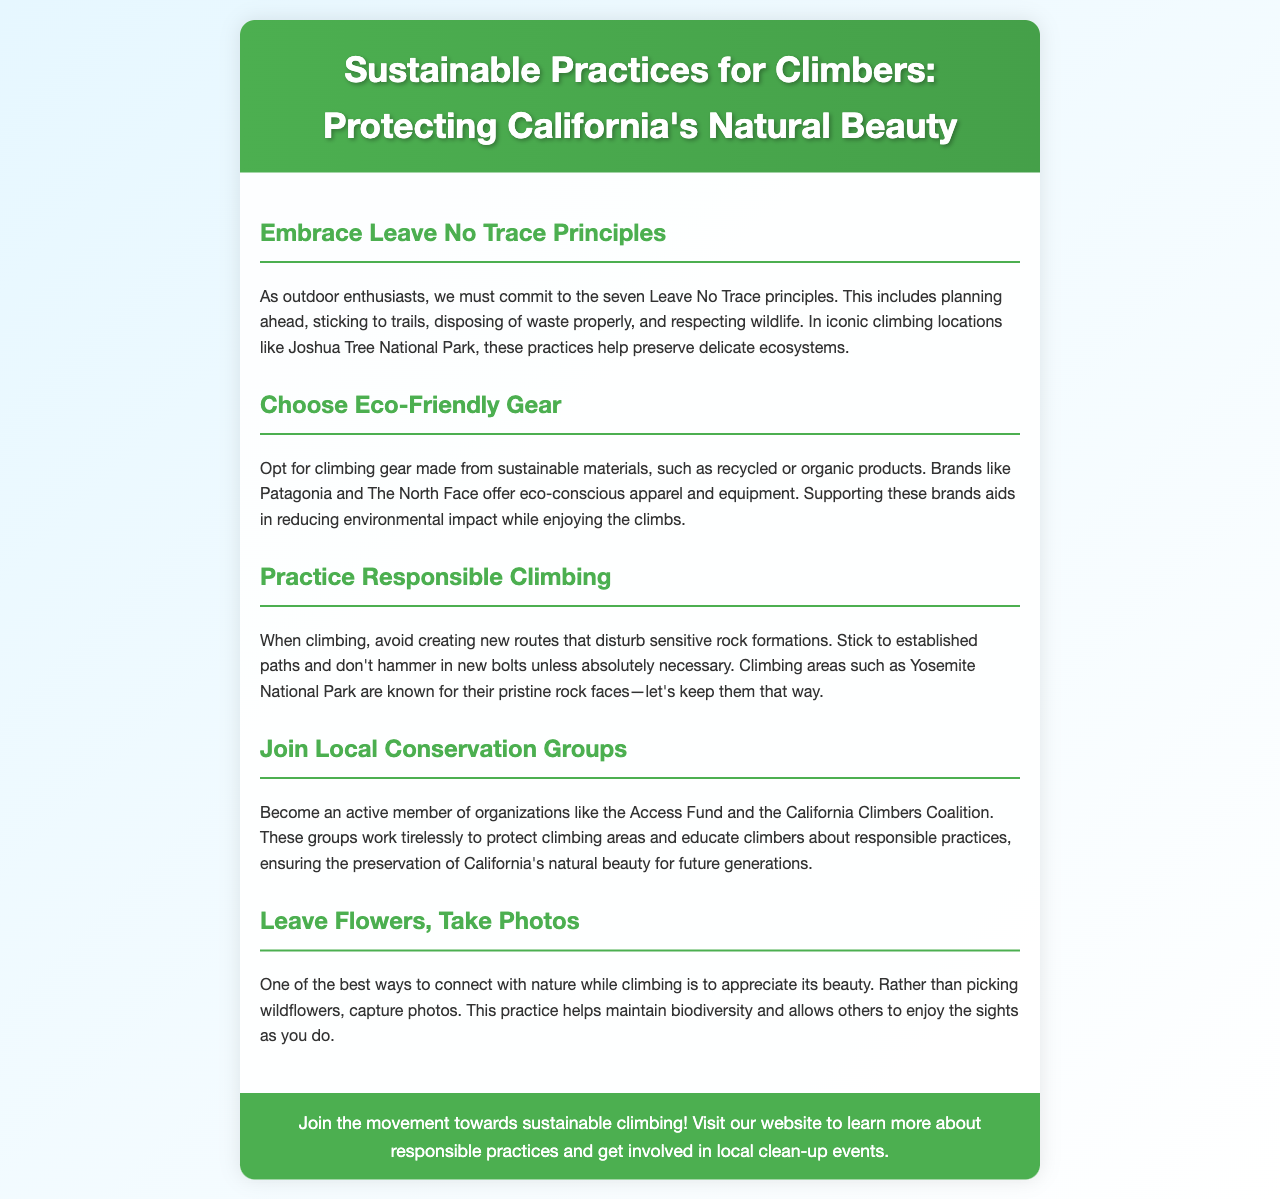what are the seven Leave No Trace principles? The document states that climbers should commit to the seven Leave No Trace principles, which include planning ahead, sticking to trails, disposing of waste properly, and respecting wildlife.
Answer: Leave No Trace principles which brands offer eco-conscious apparel and equipment? The document mentions brands like Patagonia and The North Face as examples of those offering eco-conscious apparel and equipment.
Answer: Patagonia and The North Face what should climbers avoid doing to protect rock formations? The document advises climbers to avoid creating new routes that disturb sensitive rock formations.
Answer: Creating new routes which organization is mentioned as working to protect climbing areas? The Access Fund is mentioned in the document as an organization working to protect climbing areas.
Answer: Access Fund what unique practice is suggested instead of picking wildflowers? The document suggests capturing photos instead of picking wildflowers, allowing others to enjoy the sights.
Answer: Taking photos how can climbers get involved in sustainable practices? Climbers can join local conservation groups like the California Climbers Coalition and participate in responsible practices.
Answer: Join local conservation groups what type of gradient is used in the document's background? The background of the document is described as having a linear gradient.
Answer: Linear gradient what color are the headings in the document? The document specifies that the headings are colored green.
Answer: Green 